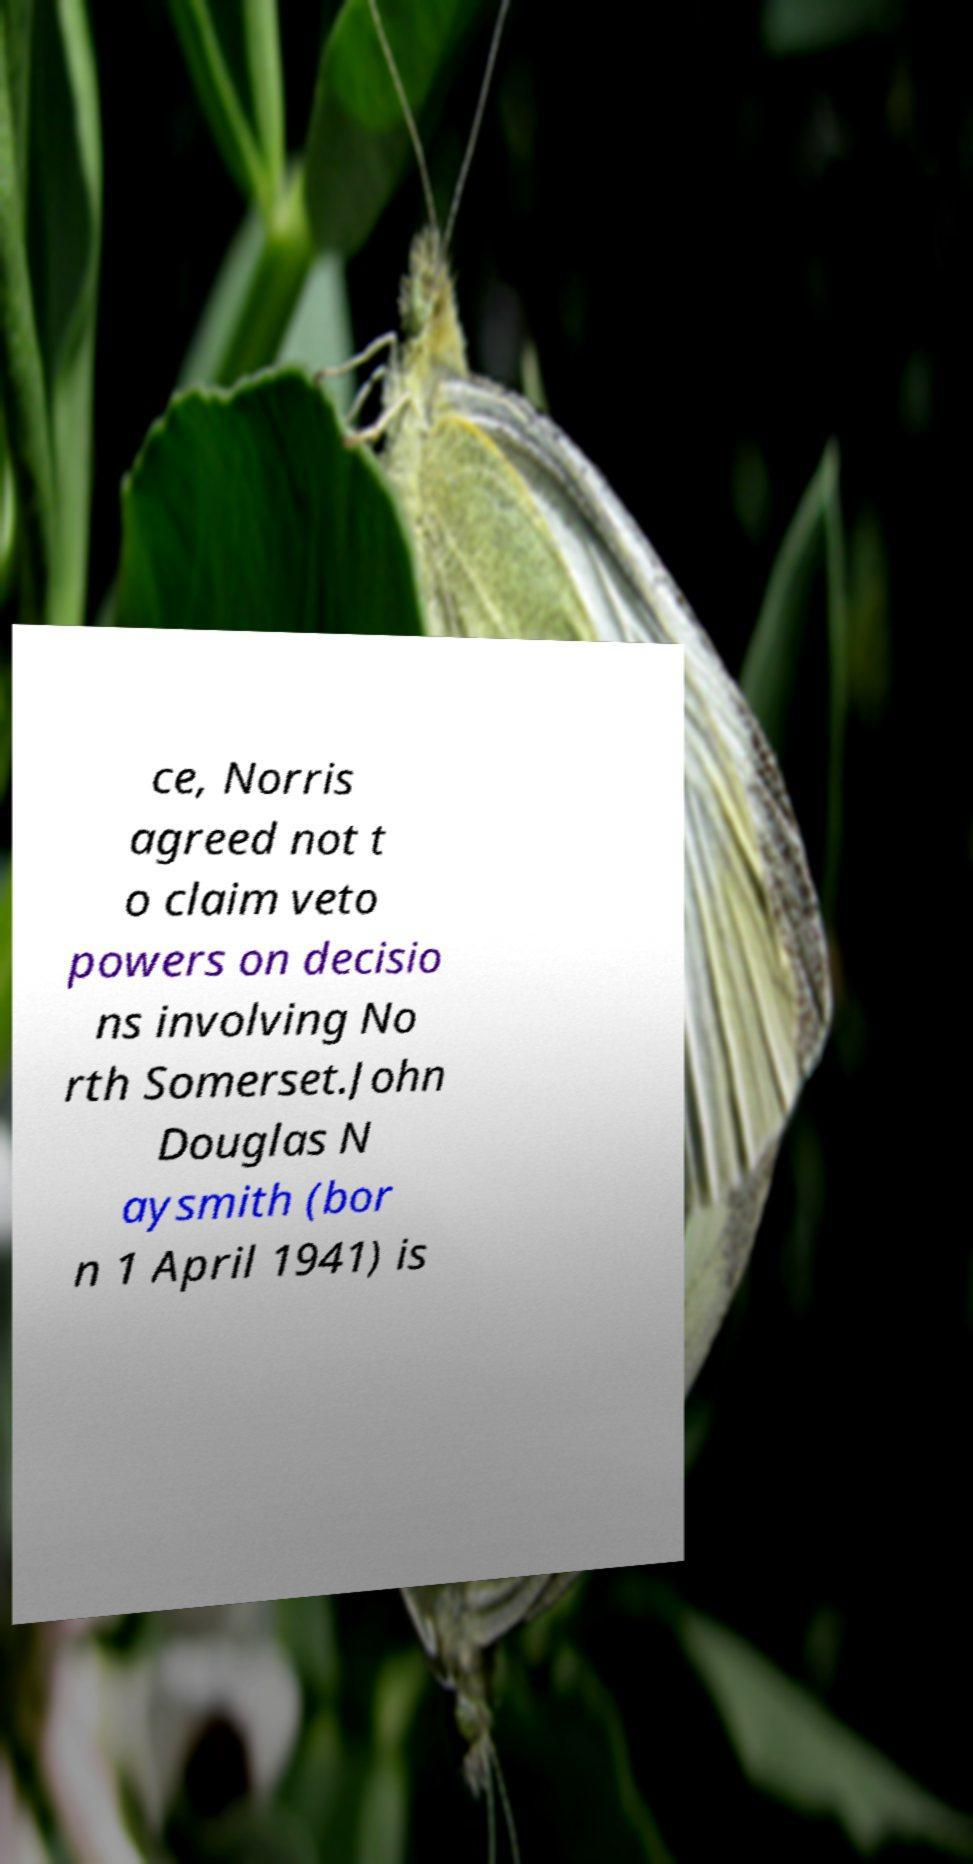I need the written content from this picture converted into text. Can you do that? ce, Norris agreed not t o claim veto powers on decisio ns involving No rth Somerset.John Douglas N aysmith (bor n 1 April 1941) is 